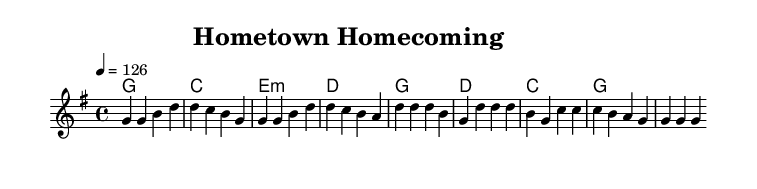What is the key signature of this music? The key signature is G major, which has one sharp (F#). This can be determined from the key signature indicated in the global section of the music that shows the notation for G major.
Answer: G major What is the time signature of this music? The time signature is 4/4, which is commonly known as common time. This is indicated at the beginning in the global section where the time signature is specified.
Answer: 4/4 What is the tempo marking for this piece? The tempo marking is indicated as quarter note equals 126. It shows how many beats per minute the piece should be played, and it is located alongside the time signature in the global section.
Answer: 126 How many measures are in the verse section? The verse section consists of 4 measures, which can be counted by looking at the melody section where the bars are segmented. Each set of notes separated by vertical lines represents one measure.
Answer: 4 Which chord follows the D major chord in the chorus? The chord that follows the D major chord in the chorus is the C major chord, as seen in the chord progressions listed in the harmonies section that follow the stated order in the chorus.
Answer: C What theme is celebrated in this song? The theme celebrated in this song is about small-town reunions, which is reflected in the lyrics, specifically in the chorus that mentions belonging to a small town. This captures the essence of reminiscing about hometowns.
Answer: Small-town reunions What type of lyrics is featured in this music? The lyrics feature a narrative style that describes personal experiences and feelings associated with hometown life and community connections, typical of country rock lyrics. This can be analyzed by looking at the lyrical content provided.
Answer: Narrative style 